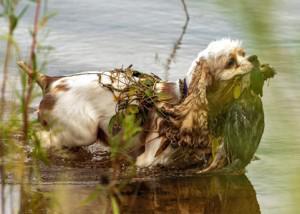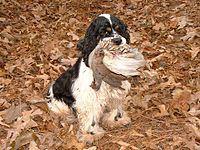The first image is the image on the left, the second image is the image on the right. Analyze the images presented: Is the assertion "Each image shows a dog on dry land carrying a bird in its mouth." valid? Answer yes or no. No. The first image is the image on the left, the second image is the image on the right. Considering the images on both sides, is "Each image shows a spaniel carrying a bird in its mouth across the ground." valid? Answer yes or no. No. 